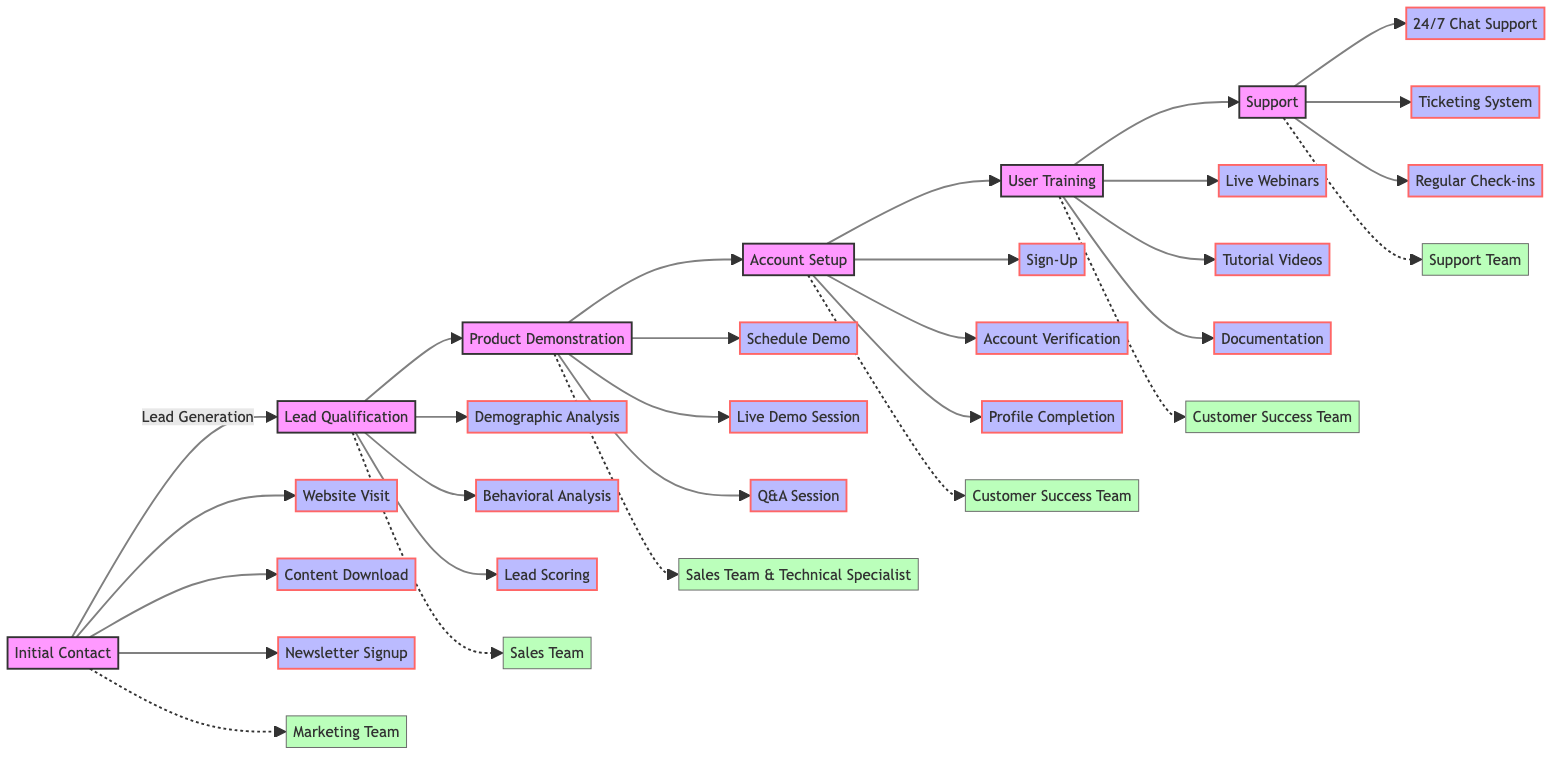What is the first stage of the workflow? The first stage of the workflow is shown as "Initial Contact" at the leftmost position of the flowchart.
Answer: Initial Contact How many key activities are associated with the "Account Setup" stage? The "Account Setup" stage lists three key activities: Sign-Up, Account Verification, and Profile Completion. Counting these gives us a total of three activities.
Answer: 3 Which team is responsible for "Product Demonstration"? The "Product Demonstration" stage cites two responsible teams: the Sales Team and the Technical Specialist, making both responsible for this stage.
Answer: Sales Team & Technical Specialist What tools are used during the "User Training" stage? The "User Training" stage mentions two specific tools: LMS and Knowledge Base, indicating these are employed during this stage.
Answer: LMS, Knowledge Base In which stage does lead scoring occur? The diagram outlines that lead scoring is a key activity that takes place in the "Lead Qualification" stage of the workflow.
Answer: Lead Qualification How many total stages are there in the diagram? By counting the flow from "Initial Contact" to "Support," there are six total stages represented in the diagram.
Answer: 6 Which tool is associated with "24/7 Chat Support"? In the "Support" stage, it is indicated that the tool used for "24/7 Chat Support" is categorized under "Customer Support Software."
Answer: Customer Support Software What is the last stage in the customer onboarding workflow? The last stage in the workflow is noted as "Support," which is positioned at the rightmost part of the flowchart.
Answer: Support Which key activity follows "Schedule Demo"? Following "Schedule Demo" in the "Product Demonstration" stage is the activity called "Live Demo Session," as per the flowchart's sequential arrangement.
Answer: Live Demo Session 